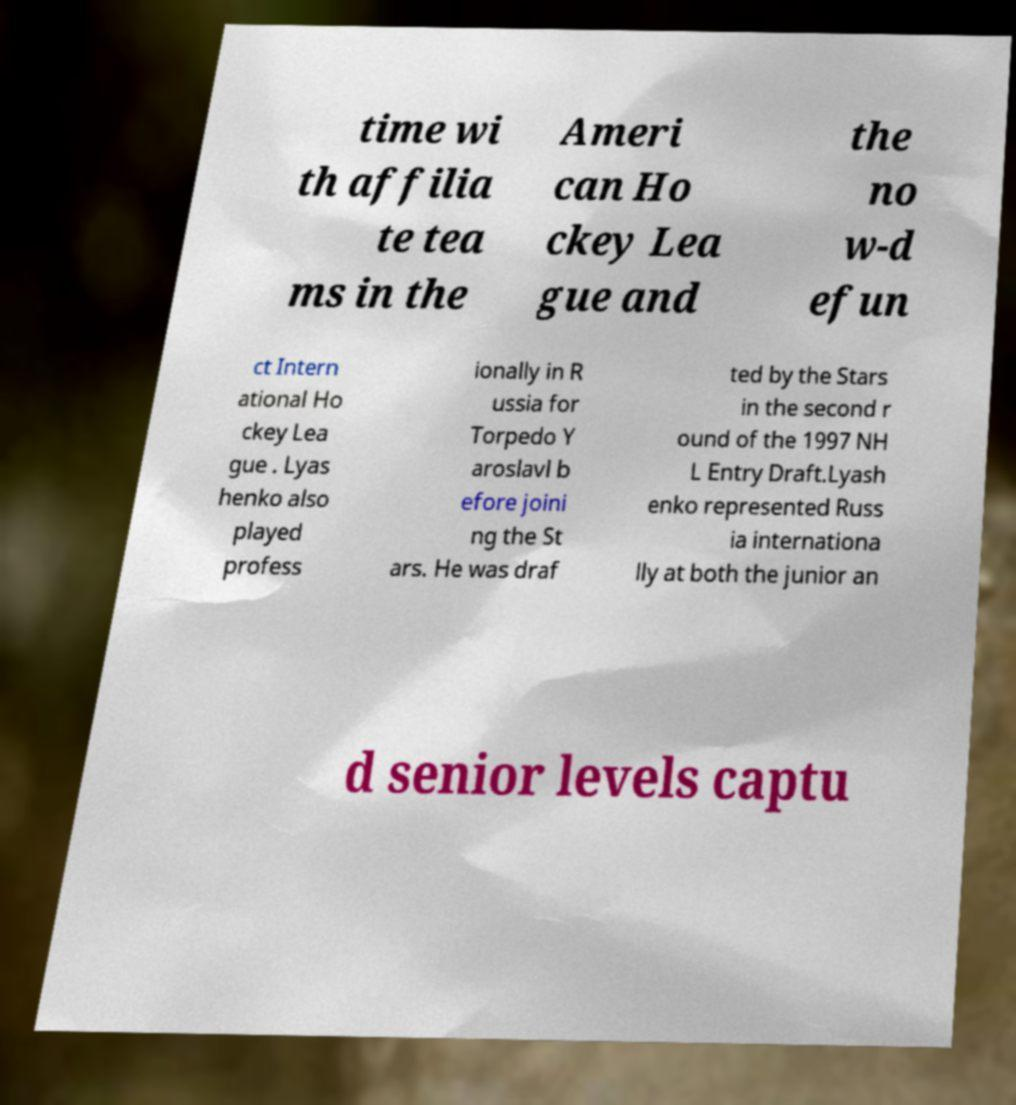I need the written content from this picture converted into text. Can you do that? time wi th affilia te tea ms in the Ameri can Ho ckey Lea gue and the no w-d efun ct Intern ational Ho ckey Lea gue . Lyas henko also played profess ionally in R ussia for Torpedo Y aroslavl b efore joini ng the St ars. He was draf ted by the Stars in the second r ound of the 1997 NH L Entry Draft.Lyash enko represented Russ ia internationa lly at both the junior an d senior levels captu 